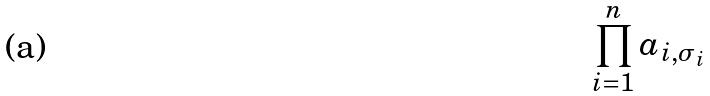Convert formula to latex. <formula><loc_0><loc_0><loc_500><loc_500>\prod _ { i = 1 } ^ { n } a _ { i , \sigma _ { i } }</formula> 